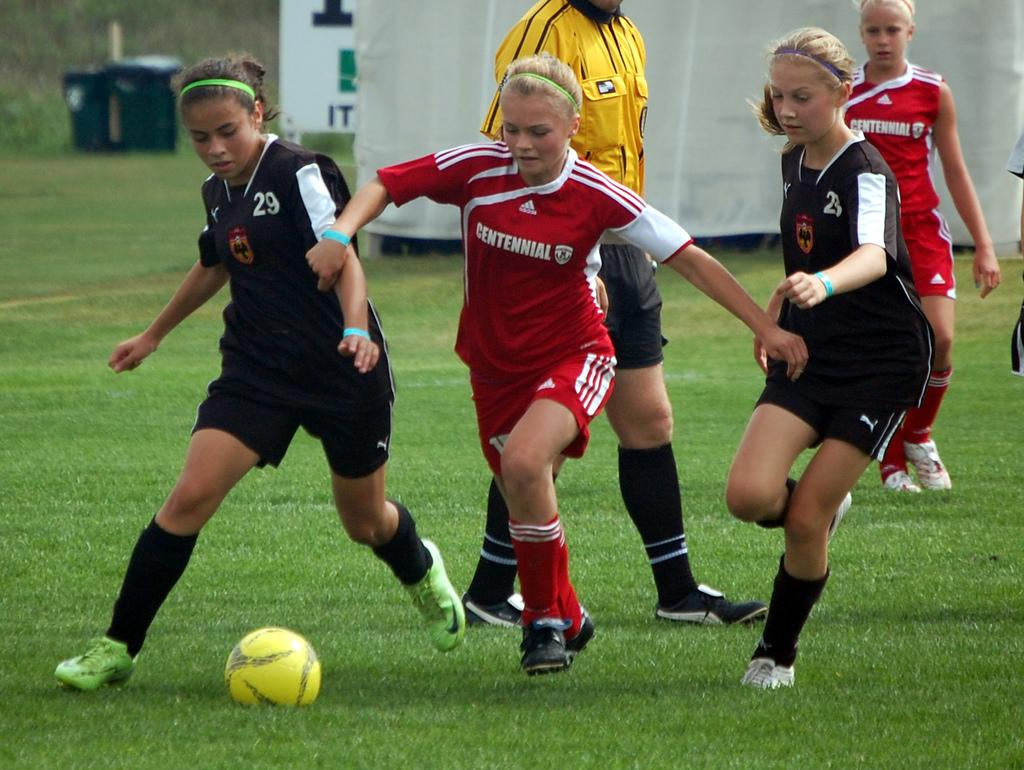<image>
Provide a brief description of the given image. a couple of girls playing soccer with one of them wearing a jersey that says 'centennial' on it 